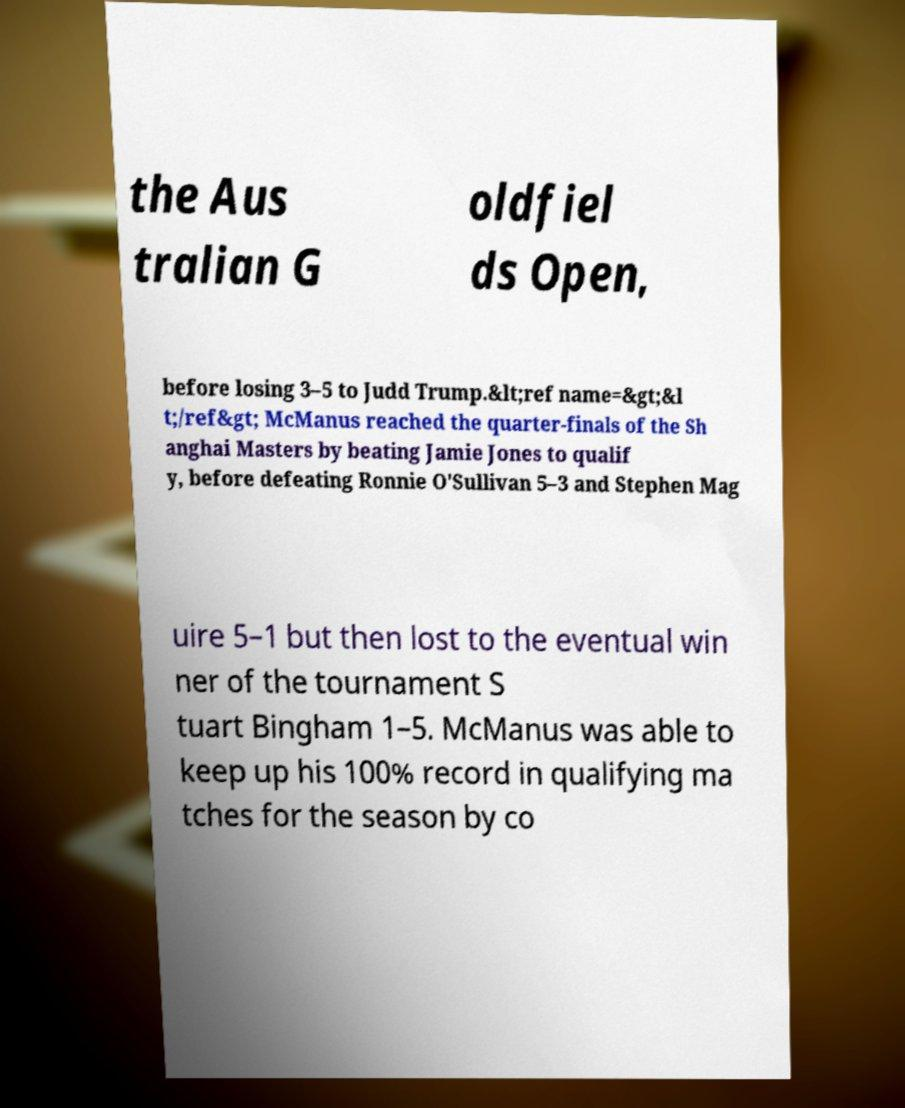There's text embedded in this image that I need extracted. Can you transcribe it verbatim? the Aus tralian G oldfiel ds Open, before losing 3–5 to Judd Trump.&lt;ref name=&gt;&l t;/ref&gt; McManus reached the quarter-finals of the Sh anghai Masters by beating Jamie Jones to qualif y, before defeating Ronnie O'Sullivan 5–3 and Stephen Mag uire 5–1 but then lost to the eventual win ner of the tournament S tuart Bingham 1–5. McManus was able to keep up his 100% record in qualifying ma tches for the season by co 